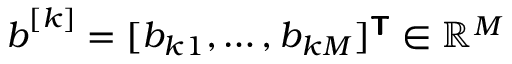<formula> <loc_0><loc_0><loc_500><loc_500>b ^ { [ k ] } = [ b _ { k 1 } , \dots , b _ { k M } ] ^ { T } \in \mathbb { R } ^ { M }</formula> 